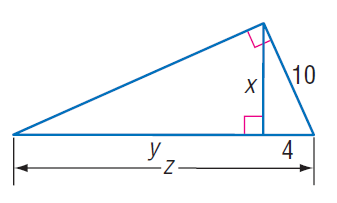Question: Find x.
Choices:
A. 6
B. 2 \sqrt { 21 }
C. 10
D. 2 \sqrt { 29 }
Answer with the letter. Answer: B Question: Find z.
Choices:
A. 17
B. 20
C. 21
D. 25
Answer with the letter. Answer: D Question: Find y.
Choices:
A. 14
B. 17
C. 21
D. 25
Answer with the letter. Answer: C 